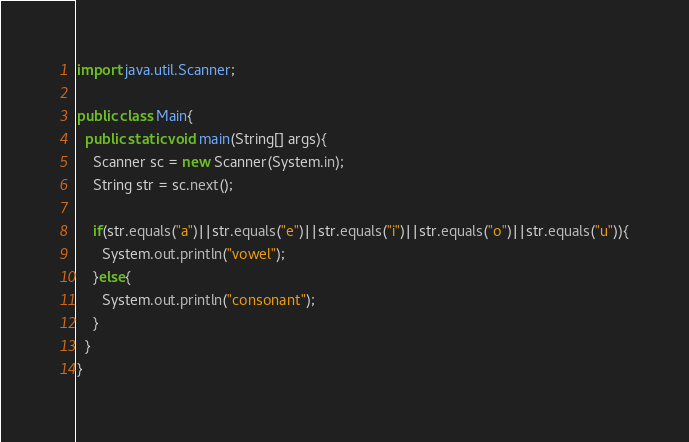<code> <loc_0><loc_0><loc_500><loc_500><_Java_>import java.util.Scanner;

public class Main{
  public static void main(String[] args){
    Scanner sc = new Scanner(System.in);
    String str = sc.next();

    if(str.equals("a")||str.equals("e")||str.equals("i")||str.equals("o")||str.equals("u")){
      System.out.println("vowel");
    }else{
      System.out.println("consonant");
    }
  }
}</code> 